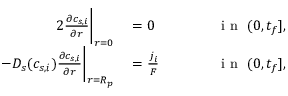Convert formula to latex. <formula><loc_0><loc_0><loc_500><loc_500>\begin{array} { r l r l } { { 2 } \frac { \partial c _ { s , i } } { \partial r } \left | _ { r = 0 } } & = 0 } & { \quad } & i n \ ( 0 , t _ { f } ] , } \\ { - D _ { s } ( c _ { s , i } ) \frac { \partial c _ { s , i } } { \partial r } \right | _ { r = R _ { p } } } & = \frac { j _ { i } } { F } } & i n \ ( 0 , t _ { f } ] , } \end{array}</formula> 